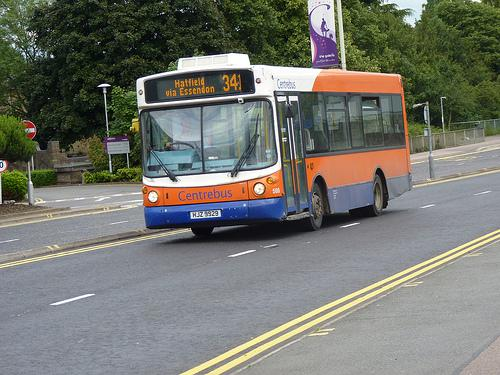Question: what color is the road?
Choices:
A. Grey.
B. Black.
C. Brown.
D. White.
Answer with the letter. Answer: A Question: who is present?
Choices:
A. Nobody.
B. Everyone.
C. Half  the class.
D. The players.
Answer with the letter. Answer: A Question: what is present?
Choices:
A. The students.
B. The children.
C. The teachers.
D. A bus.
Answer with the letter. Answer: D 